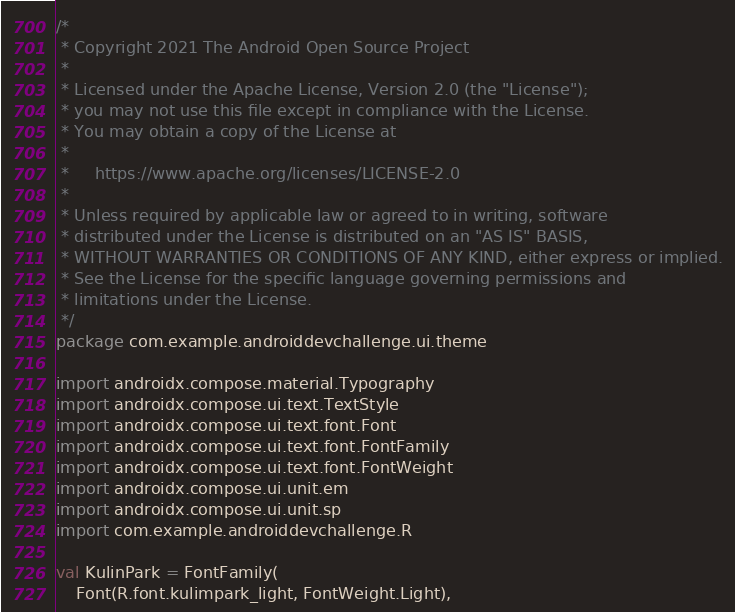<code> <loc_0><loc_0><loc_500><loc_500><_Kotlin_>/*
 * Copyright 2021 The Android Open Source Project
 *
 * Licensed under the Apache License, Version 2.0 (the "License");
 * you may not use this file except in compliance with the License.
 * You may obtain a copy of the License at
 *
 *     https://www.apache.org/licenses/LICENSE-2.0
 *
 * Unless required by applicable law or agreed to in writing, software
 * distributed under the License is distributed on an "AS IS" BASIS,
 * WITHOUT WARRANTIES OR CONDITIONS OF ANY KIND, either express or implied.
 * See the License for the specific language governing permissions and
 * limitations under the License.
 */
package com.example.androiddevchallenge.ui.theme

import androidx.compose.material.Typography
import androidx.compose.ui.text.TextStyle
import androidx.compose.ui.text.font.Font
import androidx.compose.ui.text.font.FontFamily
import androidx.compose.ui.text.font.FontWeight
import androidx.compose.ui.unit.em
import androidx.compose.ui.unit.sp
import com.example.androiddevchallenge.R

val KulinPark = FontFamily(
    Font(R.font.kulimpark_light, FontWeight.Light),</code> 